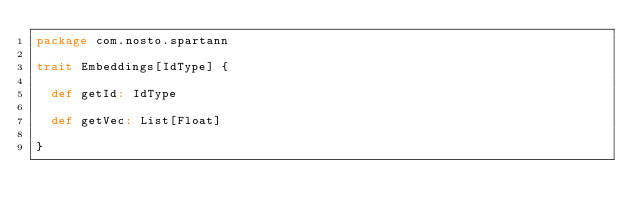<code> <loc_0><loc_0><loc_500><loc_500><_Scala_>package com.nosto.spartann

trait Embeddings[IdType] {

  def getId: IdType

  def getVec: List[Float]

}
</code> 